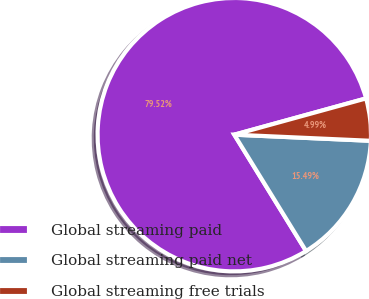Convert chart to OTSL. <chart><loc_0><loc_0><loc_500><loc_500><pie_chart><fcel>Global streaming paid<fcel>Global streaming paid net<fcel>Global streaming free trials<nl><fcel>79.52%<fcel>15.49%<fcel>4.99%<nl></chart> 